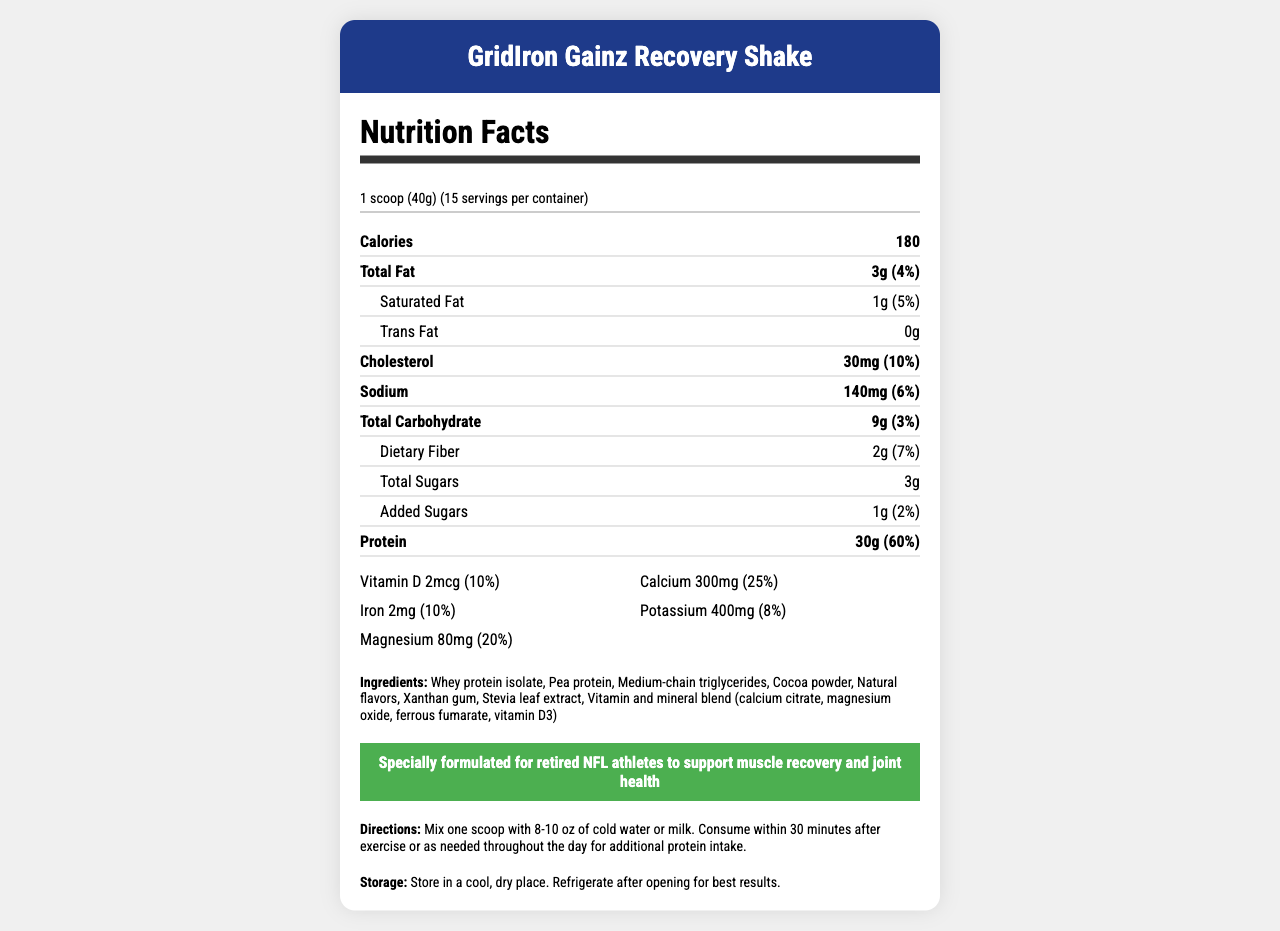what is the serving size for GridIron Gainz Recovery Shake? The serving size is specified as "1 scoop (40g)" in the document.
Answer: 1 scoop (40g) how many servings are there per container? The document clearly mentions that there are 15 servings per container.
Answer: 15 how many calories are in each serving? The Nutrition Facts label lists the calorie count as 180 per serving.
Answer: 180 calories what percentage of daily value does the protein content represent? The document specifies that the protein content is 30g, which represents 60% of the daily value.
Answer: 60% what is the amount of calcium per serving? The document lists the calcium content as 300mg per serving.
Answer: 300mg which vitamin or mineral has the lowest daily value percentage? A. Vitamin D B. Iron C. Potassium D. Magnesium Vitamin D has the lowest daily value percentage at 10%.
Answer: A what is one of the potential allergens in the product? A. Soy B. Egg C. Tree nuts D. All of the above The product is manufactured in a facility that processes all of these allergens: soy, egg, tree nuts, and wheat.
Answer: D does the product contain any trans fats? The document specifies that the trans fat content is 0g.
Answer: No is this product specially formulated for retired NFL athletes? The claim section states that it is "specially formulated for retired NFL athletes to support muscle recovery and joint health".
Answer: Yes what are the directions for consuming this recovery shake? The document provides explicit directions for consumption in a dedicated section.
Answer: Mix one scoop with 8-10 oz of cold water or milk. Consume within 30 minutes after exercise or as needed throughout the day for additional protein intake. describe the entire document or the main idea. The document provides comprehensive information about a high-protein recovery shake, its nutritional benefits, and consumption guidelines.
Answer: The document is a detailed nutrition facts label for GridIron Gainz Recovery Shake, specially designed for retired NFL athletes. It includes nutritional information per serving, including calories, macronutrients, vitamins, and minerals. It also provides details on serving size, allergens, ingredients, specific health claims, directions for consumption, and storage instructions. what ingredients are used in the product? The ingredients are listed towards the end of the document.
Answer: Whey protein isolate, Pea protein, Medium-chain triglycerides, Cocoa powder, Natural flavors, Xanthan gum, Stevia leaf extract, Vitamin and mineral blend (calcium citrate, magnesium oxide, ferrous fumarate, vitamin D3) what is the daily value percentage of dietary fiber provided by one serving? The dietary fiber content is listed as 2g, which represents 7% of the daily value.
Answer: 7% how much sodium is in each serving? The sodium content per serving is specified as 140mg.
Answer: 140mg is the document clear about how to store the product after opening? The storage section clearly states to store in a cool, dry place and refrigerate after opening for best results.
Answer: Yes what type of sweetener is used in the product? The ingredient list specifies Stevia leaf extract as the sweetener used in the product.
Answer: Stevia leaf extract can we determine the exact blend of vitamins and minerals in this product from the document? The document lists the vitamin and mineral blend as containing calcium citrate, magnesium oxide, ferrous fumarate, and vitamin D3.
Answer: Yes how much cholesterol is in one serving? The document specifies that each serving contains 30mg of cholesterol.
Answer: 30mg how many grams of total carbohydrates are there in one serving? The total carbohydrate content per serving is listed as 9g.
Answer: 9g is the nutritional information for a light or heavy exercise regimen provided? The document does not specify whether the nutritional information is tailored for light or heavy exercise regimens. It only mentions it is for muscle recovery and joint health for retired athletes.
Answer: Not enough information 